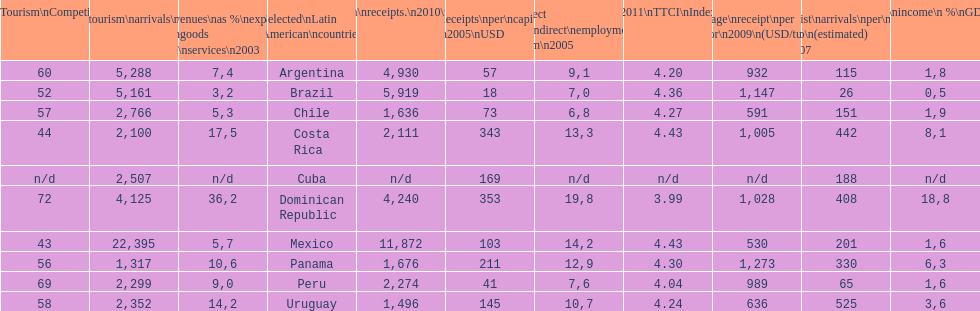What is the last country listed on this chart? Uruguay. 